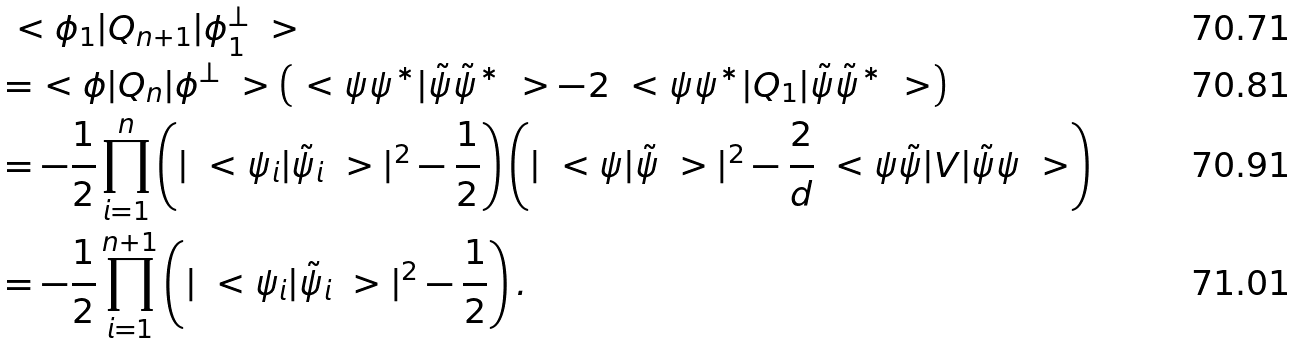<formula> <loc_0><loc_0><loc_500><loc_500>& \ < \phi _ { 1 } | Q _ { n + 1 } | \phi _ { 1 } ^ { \bot } \ > \\ & = \ < \phi | Q _ { n } | \phi ^ { \bot } \ > \left ( \ < \psi \psi ^ { * } | \tilde { \psi } \tilde { \psi } ^ { * } \ > - 2 \ < \psi \psi ^ { * } | Q _ { 1 } | \tilde { \psi } \tilde { \psi } ^ { * } \ > \right ) \\ & = - \frac { 1 } { 2 } \prod _ { i = 1 } ^ { n } \left ( | \ < \psi _ { i } | \tilde { \psi } _ { i } \ > | ^ { 2 } - \frac { 1 } { 2 } \right ) \left ( | \ < \psi | \tilde { \psi } \ > | ^ { 2 } - \frac { 2 } { d } \ < \psi \tilde { \psi } | V | \tilde { \psi } \psi \ > \right ) \\ & = - \frac { 1 } { 2 } \prod _ { i = 1 } ^ { n + 1 } \left ( | \ < \psi _ { i } | \tilde { \psi } _ { i } \ > | ^ { 2 } - \frac { 1 } { 2 } \right ) .</formula> 